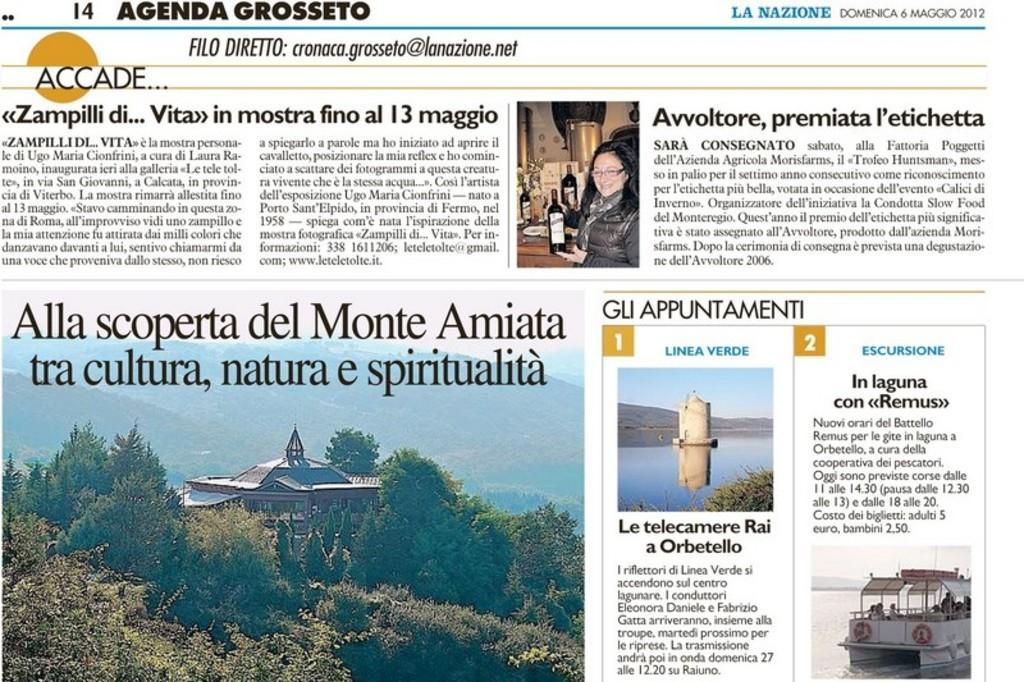Can you describe this image briefly? This is a picture of newspaper. In that there are so many articles. At the bottom there are trees and building. In the bottom right corner there is a boat. There is a person in the middle. There is something written in the newspaper. 